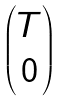Convert formula to latex. <formula><loc_0><loc_0><loc_500><loc_500>\begin{pmatrix} T \\ 0 \end{pmatrix}</formula> 